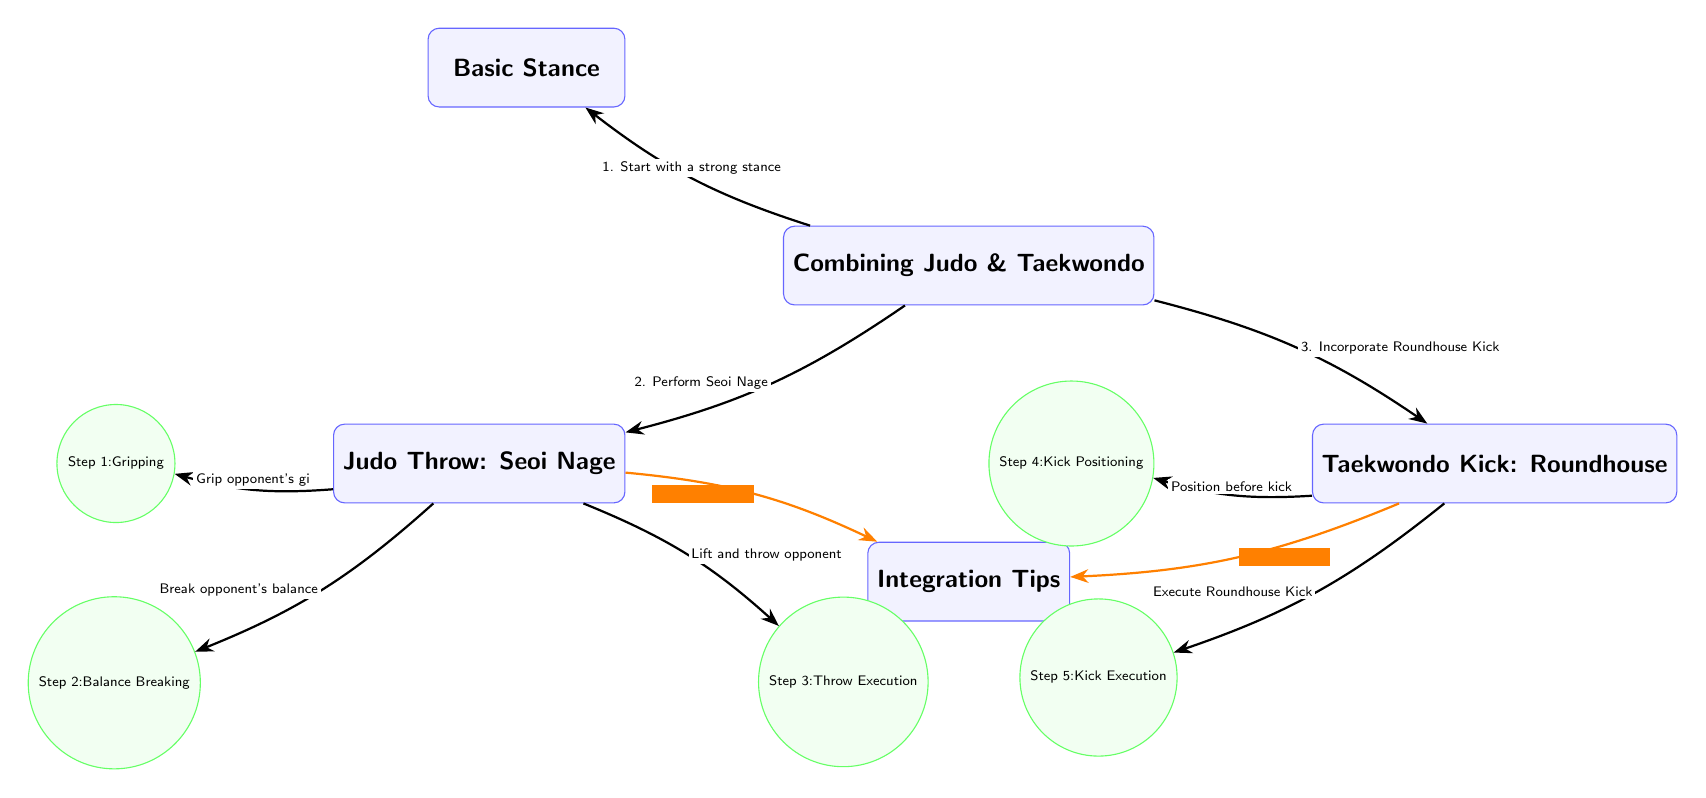What is the main focus of the diagram? The central node clearly states "Combining Judo & Taekwondo," which signifies that the main focus of the diagram is the integration of these two martial arts disciplines.
Answer: Combining Judo & Taekwondo How many steps are outlined for the Judo throw? There are three steps outlined under the Judo section: Gripping, Balance Breaking, and Throw Execution. By counting these steps, we determine the total.
Answer: 3 What kick is incorporated into the sequence? The diagram indicates that the kick included in the process is the Roundhouse Kick, as shown in the Taekwondo section of the diagram.
Answer: Roundhouse Kick What should you ensure regarding timing, according to the tips? The tips indicate "Ensure timing," specifically related to the integration of Taekwondo, suggesting that timing is crucial when executing the combination techniques.
Answer: Ensure timing What is the first step required for a Judo throw? According to the diagram, the first step in performing a Judo throw is "Gripping," which is the initial action for executing the Seoi Nage technique.
Answer: Gripping How many nodes represent steps for the Taekwondo kick? There are two distinct steps represented for Taekwondo, which are "Kick Positioning" and "Kick Execution."
Answer: 2 What action follows balance breaking in the Judo sequence? The action that follows "Balance Breaking" in the Judo sequence is "Throw Execution," meaning after breaking balance, the next step is to execute the throw.
Answer: Throw Execution What is suggested for fluidity in the integration tips? The tips near Judo suggest "Practice fluidity," indicating the importance of smooth transitions between techniques for effective integration.
Answer: Practice fluidity What is the relationship between the Basic Stance and the two martial arts techniques? The Basic Stance is the initiating point from which both the Judo throw and Taekwondo kick are executed, serving as the foundational position before performing either technique.
Answer: Initiating point 